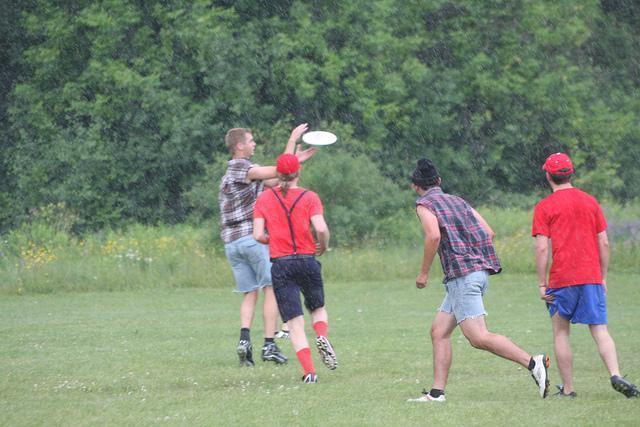How many people are wearing red?
Give a very brief answer. 2. How many teammates are in this picture?
Give a very brief answer. 4. How many men are playing?
Give a very brief answer. 4. How many people are in the picture?
Give a very brief answer. 4. 